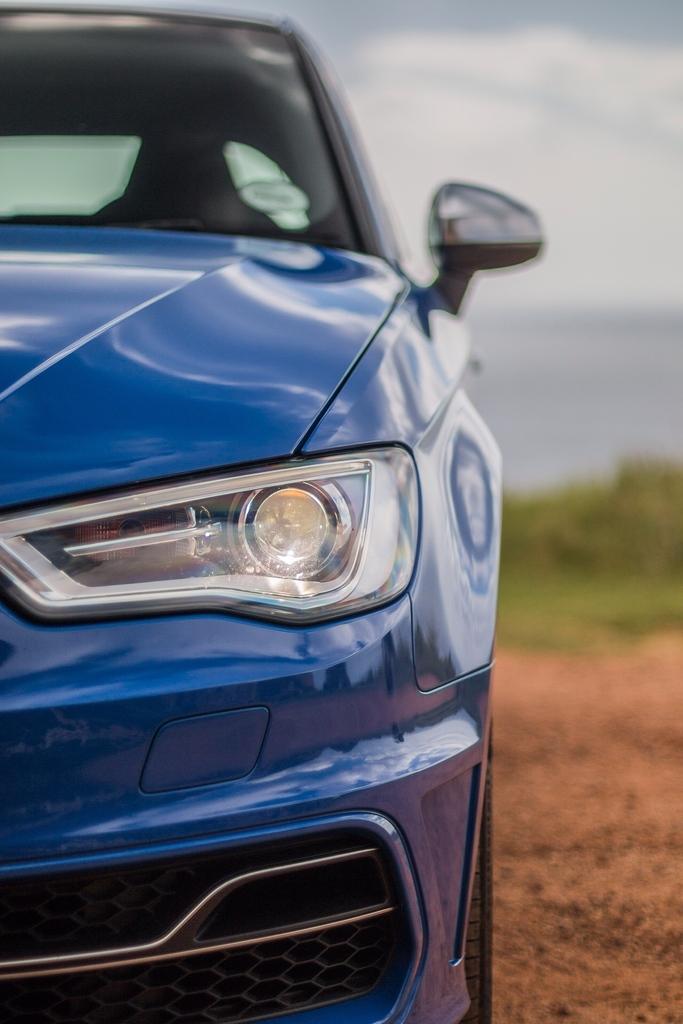How would you summarize this image in a sentence or two? In this picture we can see a car on ground and in the background we can see grass and sky with clouds. 